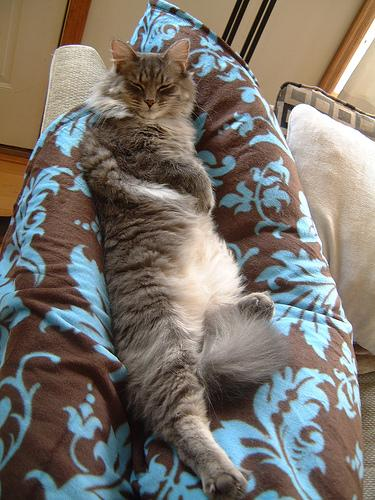Is there any furniture visible in the image, and if so, what type? Yes, there is a beige couch visible in the image. How many pillows are visible in the image and what colors are they? There are two pillows visible in the image, one white and one with squares. Describe the overall quality of the image and any noticeable imperfections. The image is of good quality and there are no noticeable imperfections. Estimate the number of objects visible in the entire image. There are approximately 41 objects visible in the entire image. Describe the sentiment or emotion portrayed in the image. The image portrays a relaxed and comfortable atmosphere with a cat lying on its back, smiling. Enumerate the visible elements in the scene that suggest the image is indoors. White wall, beige couch, pillows, white door, wood door frame, wood window frame, and pattern on the sofa. What is the primary focus of the image and what color is it? The primary focus is a gray and white cat lying on its back on a couch. Analyze the interaction between the cat and the objects surrounding it. The cat is lying on its back on a beige couch with a brown and blue blanket, interacting with the cushions and the couch in a relaxed manner. 